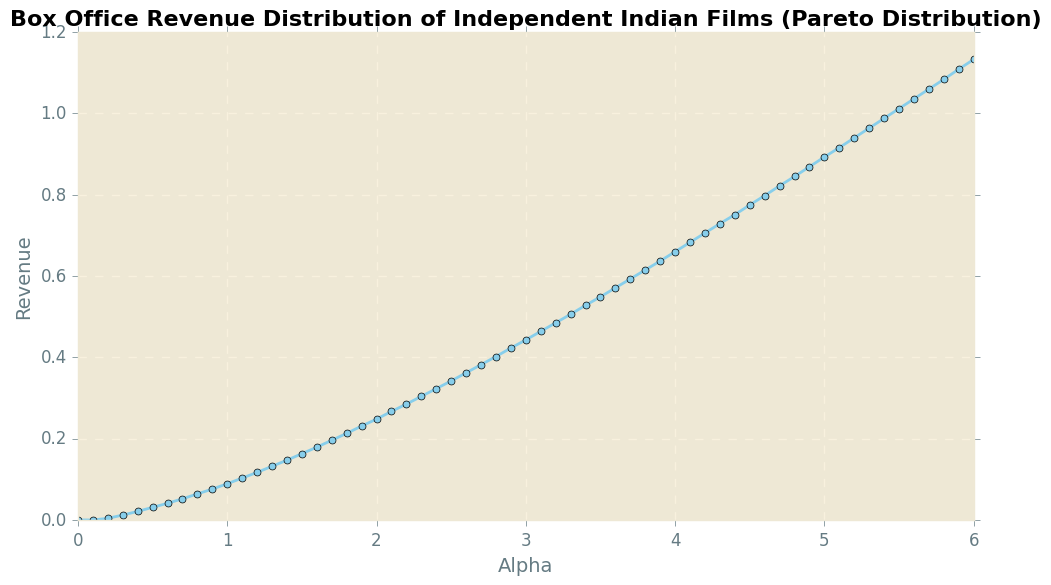What is the revenue at alpha = 2.0? To find the revenue at alpha = 2.0, locate the value on the x-axis that corresponds to alpha = 2.0 and check the corresponding y-axis value.
Answer: 0.248 How much higher is the revenue at alpha = 4.0 compared to alpha = 3.0? Locate the revenue values at alpha = 4.0 and alpha = 3.0, then subtract the revenue at alpha = 3.0 from the revenue at alpha = 4.0. Revenue at alpha = 4.0 is 0.660, and revenue at alpha = 3.0 is 0.443. The difference is 0.660 - 0.443.
Answer: 0.217 What is the average revenue between alpha = 1.0 and alpha = 2.0? Find the revenue values at alpha = 1.0, 1.1, 1.2, 1.3, 1.4, 1.5, 1.6, 1.7, 1.8, 1.9, and 2.0. Sum these values and divide by the number of data points (11). The values are 0.089, 0.103, 0.117, 0.132, 0.147, 0.163, 0.179, 0.196, 0.213, 0.231, and 0.248. The sum is 1.818. The average is 1.818 / 11.
Answer: 0.165 What is the color of the line representing the revenue data? The line color can be identified visually. From the plot description, the line is colored skyblue.
Answer: skyblue Is the revenue at alpha = 5.0 less than or greater than the revenue at alpha = 6.0? Compare the revenue values at alpha = 5.0 and alpha = 6.0. The revenue at 5.0 is 0.893, and at 6.0, it is 1.133. Since 0.893 is less than 1.133, the revenue at 5.0 is less.
Answer: Less By how much does the revenue increase from alpha = 0.0 to alpha = 6.0? Identify the revenue values at alpha = 0.0 and alpha = 6.0, then subtract the value at 0.0 from the value at 6.0. Revenue at alpha = 0.0 is 0.000, and at 6.0, it is 1.133. The difference is 1.133 - 0.000.
Answer: 1.133 